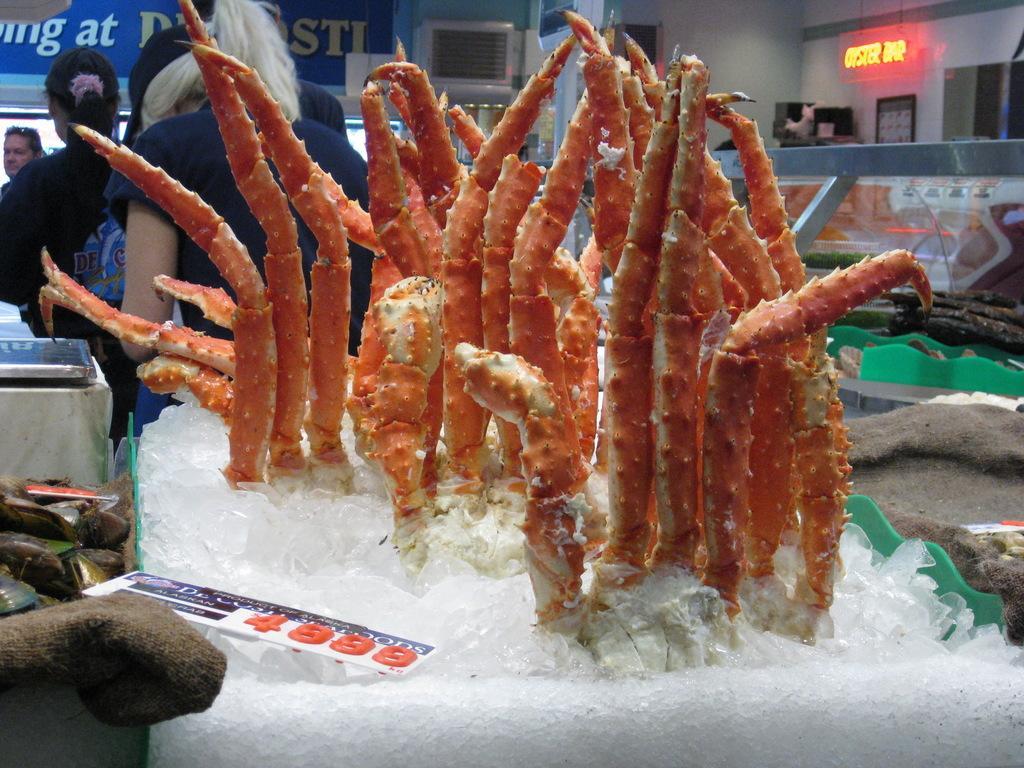How would you summarize this image in a sentence or two? In the center of the image we can see carbs placed in the ice. On the left there are boards and a table. In the background there are people standing and there is a wall. 